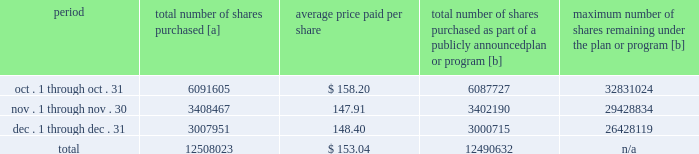Purchases of equity securities 2013 during 2018 , we repurchased 57669746 shares of our common stock at an average price of $ 143.70 .
The table presents common stock repurchases during each month for the fourth quarter of 2018 : period total number of shares purchased [a] average price paid per share total number of shares purchased as part of a publicly announced plan or program [b] maximum number of shares remaining under the plan or program [b] .
[a] total number of shares purchased during the quarter includes approximately 17391 shares delivered or attested to upc by employees to pay stock option exercise prices , satisfy excess tax withholding obligations for stock option exercises or vesting of retention units , and pay withholding obligations for vesting of retention shares .
[b] effective january 1 , 2017 , our board of directors authorized the repurchase of up to 120 million shares of our common stock by december 31 , 2020 .
These repurchases may be made on the open market or through other transactions .
Our management has sole discretion with respect to determining the timing and amount of these transactions. .
What percent of share repurchases took place in the fourth quarter? 
Computations: (12508023 / 57669746)
Answer: 0.21689. 